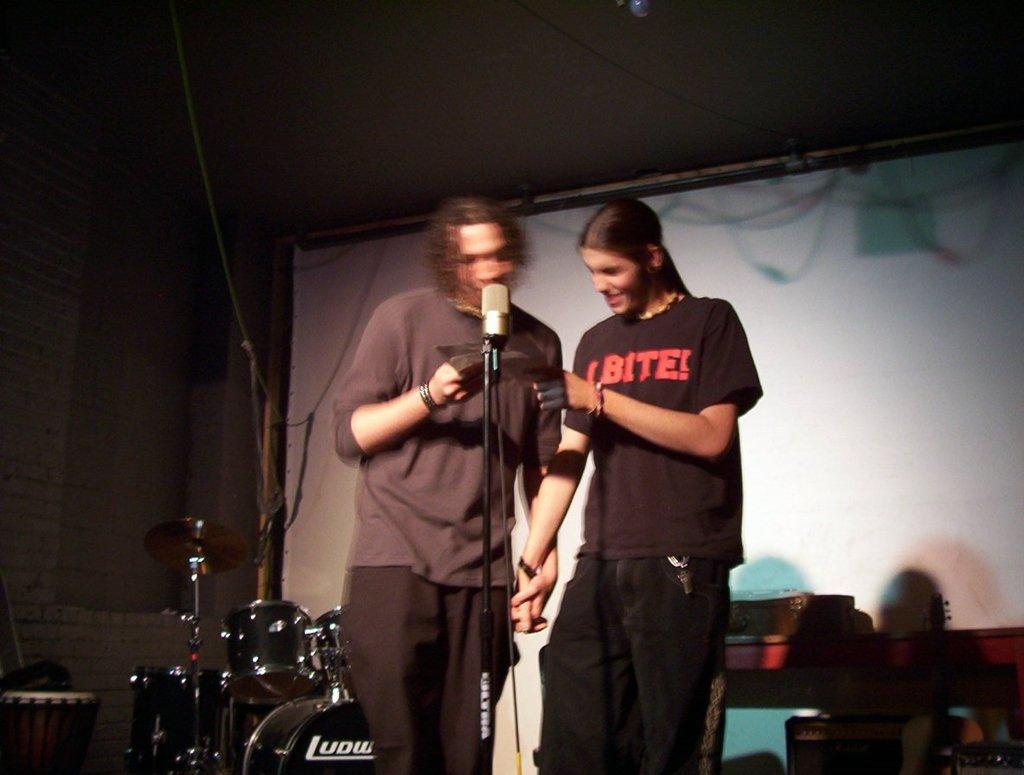Can you describe this image briefly? In this picture we can see two men standing and in front of the we can see a mic and in the backgrounder we can see drums. 